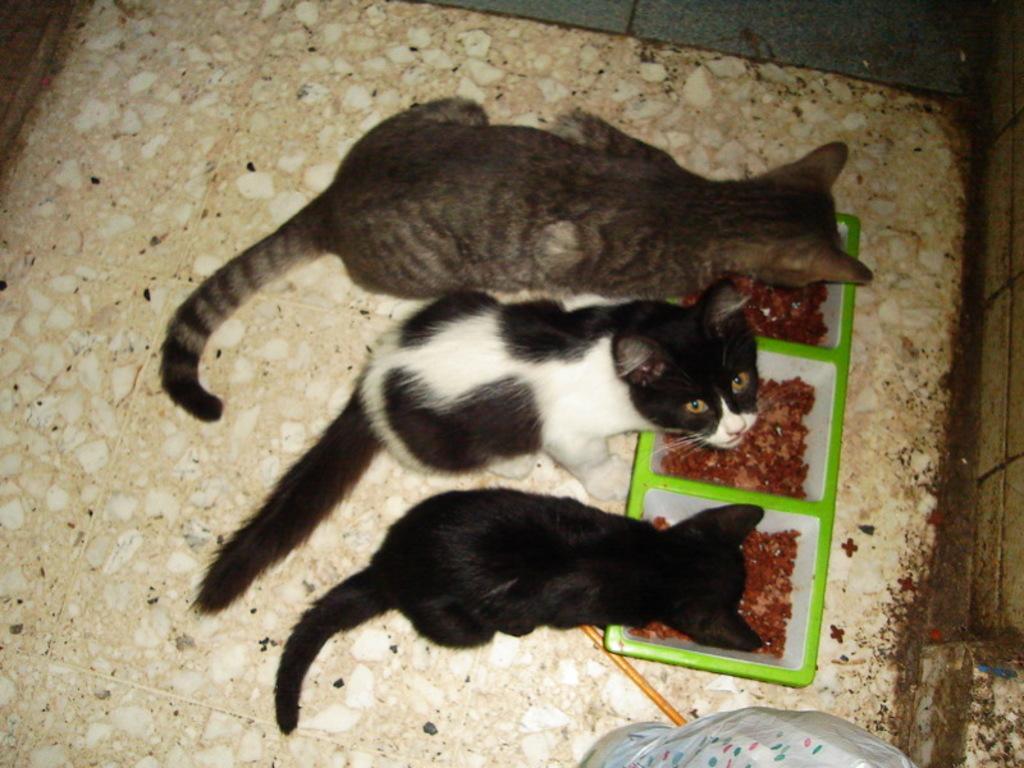Describe this image in one or two sentences. In this picture we can see three cats, in front of the cats we can find food in the bowls, and also we can see a stick. 